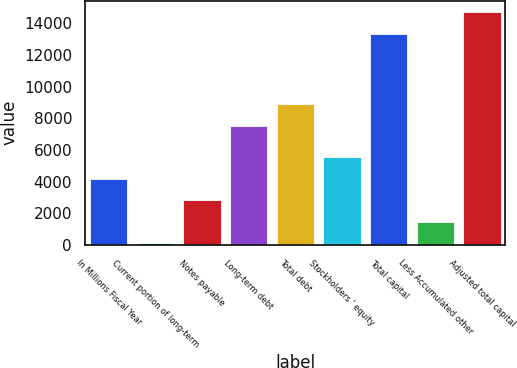Convert chart to OTSL. <chart><loc_0><loc_0><loc_500><loc_500><bar_chart><fcel>In Millions Fiscal Year<fcel>Current portion of long-term<fcel>Notes payable<fcel>Long-term debt<fcel>Total debt<fcel>Stockholders ' equity<fcel>Total capital<fcel>Less Accumulated other<fcel>Adjusted total capital<nl><fcel>4175.7<fcel>105<fcel>2818.8<fcel>7516<fcel>8872.9<fcel>5532.6<fcel>13332<fcel>1461.9<fcel>14688.9<nl></chart> 